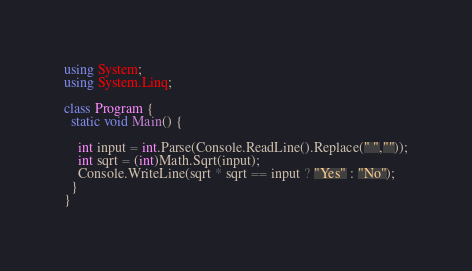Convert code to text. <code><loc_0><loc_0><loc_500><loc_500><_C#_>using System;
using System.Linq;
 
class Program {
  static void Main() {
    
    int input = int.Parse(Console.ReadLine().Replace(" ",""));
    int sqrt = (int)Math.Sqrt(input);
    Console.WriteLine(sqrt * sqrt == input ? "Yes" : "No");
  }
}</code> 